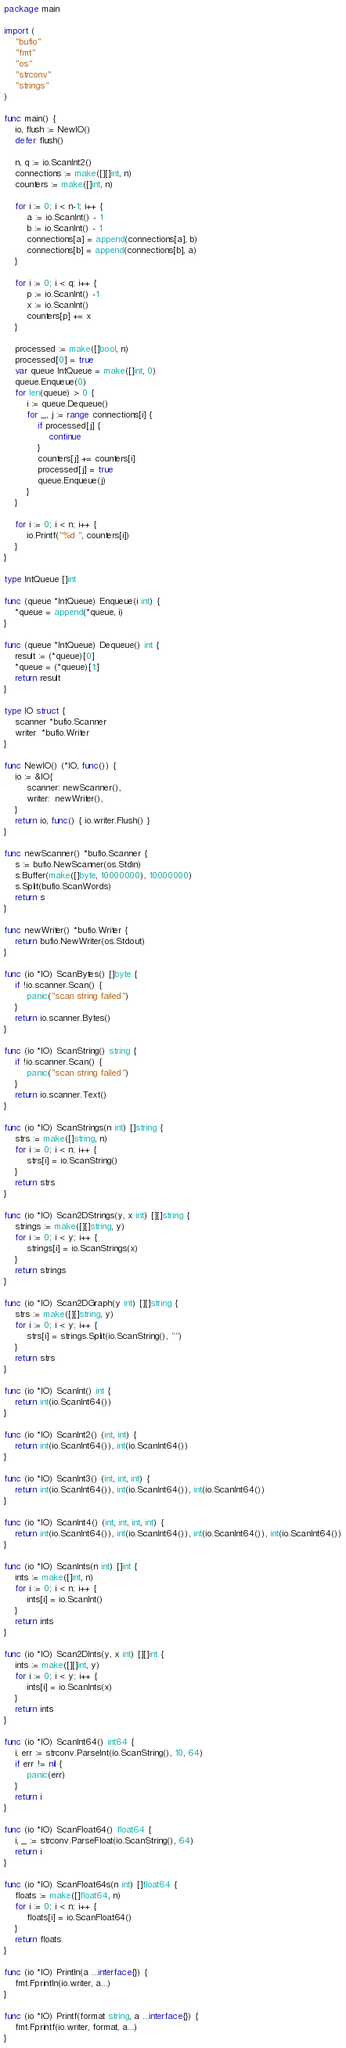Convert code to text. <code><loc_0><loc_0><loc_500><loc_500><_Go_>package main

import (
	"bufio"
	"fmt"
	"os"
	"strconv"
	"strings"
)

func main() {
	io, flush := NewIO()
	defer flush()

	n, q := io.ScanInt2()
	connections := make([][]int, n)
	counters := make([]int, n)

	for i := 0; i < n-1; i++ {
		a := io.ScanInt() - 1
		b := io.ScanInt() - 1
		connections[a] = append(connections[a], b)
		connections[b] = append(connections[b], a)
	}

	for i := 0; i < q; i++ {
		p := io.ScanInt() -1
		x := io.ScanInt()
		counters[p] += x
	}

	processed := make([]bool, n)
	processed[0] = true
	var queue IntQueue = make([]int, 0)
	queue.Enqueue(0)
	for len(queue) > 0 {
		i := queue.Dequeue()
		for _, j := range connections[i] {
			if processed[j] {
				continue
			}
			counters[j] += counters[i]
			processed[j] = true
			queue.Enqueue(j)
		}
	}

	for i := 0; i < n; i++ {
		io.Printf("%d ", counters[i])
	}
}

type IntQueue []int

func (queue *IntQueue) Enqueue(i int) {
	*queue = append(*queue, i)
}

func (queue *IntQueue) Dequeue() int {
	result := (*queue)[0]
	*queue = (*queue)[1:]
	return result
}

type IO struct {
	scanner *bufio.Scanner
	writer  *bufio.Writer
}

func NewIO() (*IO, func()) {
	io := &IO{
		scanner: newScanner(),
		writer:  newWriter(),
	}
	return io, func() { io.writer.Flush() }
}

func newScanner() *bufio.Scanner {
	s := bufio.NewScanner(os.Stdin)
	s.Buffer(make([]byte, 10000000), 10000000)
	s.Split(bufio.ScanWords)
	return s
}

func newWriter() *bufio.Writer {
	return bufio.NewWriter(os.Stdout)
}

func (io *IO) ScanBytes() []byte {
	if !io.scanner.Scan() {
		panic("scan string failed")
	}
	return io.scanner.Bytes()
}

func (io *IO) ScanString() string {
	if !io.scanner.Scan() {
		panic("scan string failed")
	}
	return io.scanner.Text()
}

func (io *IO) ScanStrings(n int) []string {
	strs := make([]string, n)
	for i := 0; i < n; i++ {
		strs[i] = io.ScanString()
	}
	return strs
}

func (io *IO) Scan2DStrings(y, x int) [][]string {
	strings := make([][]string, y)
	for i := 0; i < y; i++ {
		strings[i] = io.ScanStrings(x)
	}
	return strings
}

func (io *IO) Scan2DGraph(y int) [][]string {
	strs := make([][]string, y)
	for i := 0; i < y; i++ {
		strs[i] = strings.Split(io.ScanString(), "")
	}
	return strs
}

func (io *IO) ScanInt() int {
	return int(io.ScanInt64())
}

func (io *IO) ScanInt2() (int, int) {
	return int(io.ScanInt64()), int(io.ScanInt64())
}

func (io *IO) ScanInt3() (int, int, int) {
	return int(io.ScanInt64()), int(io.ScanInt64()), int(io.ScanInt64())
}

func (io *IO) ScanInt4() (int, int, int, int) {
	return int(io.ScanInt64()), int(io.ScanInt64()), int(io.ScanInt64()), int(io.ScanInt64())
}

func (io *IO) ScanInts(n int) []int {
	ints := make([]int, n)
	for i := 0; i < n; i++ {
		ints[i] = io.ScanInt()
	}
	return ints
}

func (io *IO) Scan2DInts(y, x int) [][]int {
	ints := make([][]int, y)
	for i := 0; i < y; i++ {
		ints[i] = io.ScanInts(x)
	}
	return ints
}

func (io *IO) ScanInt64() int64 {
	i, err := strconv.ParseInt(io.ScanString(), 10, 64)
	if err != nil {
		panic(err)
	}
	return i
}

func (io *IO) ScanFloat64() float64 {
	i, _ := strconv.ParseFloat(io.ScanString(), 64)
	return i
}

func (io *IO) ScanFloat64s(n int) []float64 {
	floats := make([]float64, n)
	for i := 0; i < n; i++ {
		floats[i] = io.ScanFloat64()
	}
	return floats
}

func (io *IO) Println(a ...interface{}) {
	fmt.Fprintln(io.writer, a...)
}

func (io *IO) Printf(format string, a ...interface{}) {
	fmt.Fprintf(io.writer, format, a...)
}
</code> 